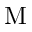Convert formula to latex. <formula><loc_0><loc_0><loc_500><loc_500>M</formula> 